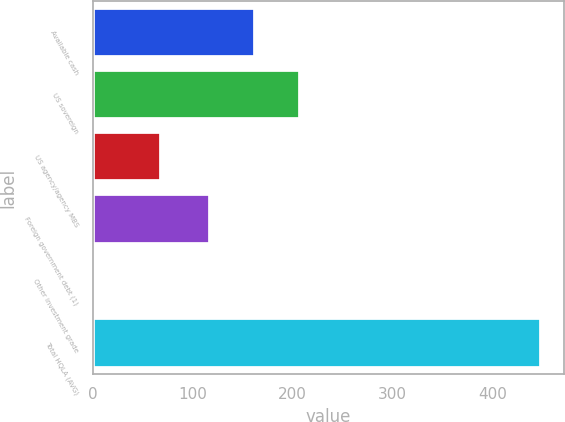Convert chart. <chart><loc_0><loc_0><loc_500><loc_500><bar_chart><fcel>Available cash<fcel>US sovereign<fcel>US agency/agency MBS<fcel>Foreign government debt (1)<fcel>Other investment grade<fcel>Total HQLA (AVG)<nl><fcel>162.29<fcel>206.98<fcel>68.7<fcel>117.6<fcel>1.7<fcel>448.6<nl></chart> 